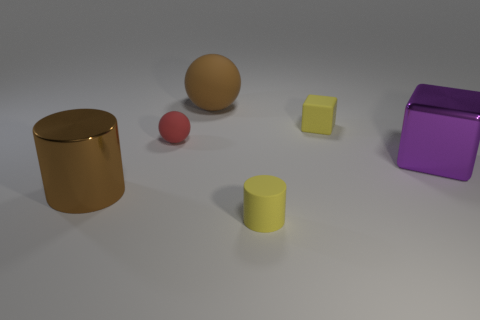Subtract all cylinders. How many objects are left? 4 Add 2 small green rubber things. How many objects exist? 8 Subtract 1 red spheres. How many objects are left? 5 Subtract 1 cubes. How many cubes are left? 1 Subtract all brown cylinders. Subtract all yellow cubes. How many cylinders are left? 1 Subtract all red cubes. How many red cylinders are left? 0 Subtract all big cyan rubber cylinders. Subtract all brown spheres. How many objects are left? 5 Add 2 large metal blocks. How many large metal blocks are left? 3 Add 6 small red balls. How many small red balls exist? 7 